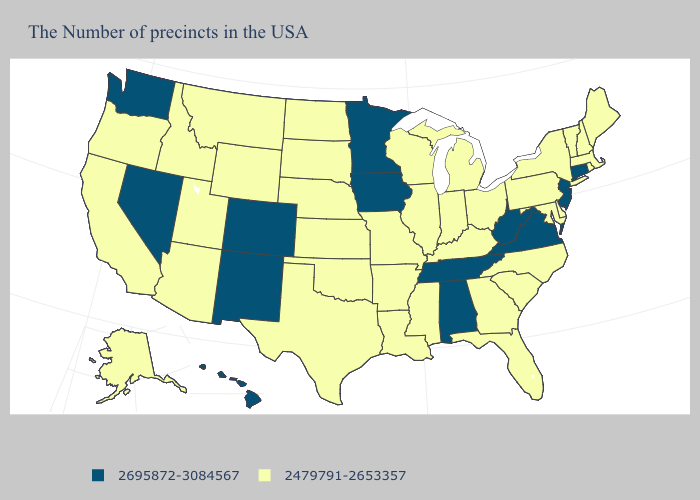Among the states that border North Carolina , does South Carolina have the lowest value?
Short answer required. Yes. Which states hav the highest value in the Northeast?
Quick response, please. Connecticut, New Jersey. Name the states that have a value in the range 2479791-2653357?
Give a very brief answer. Maine, Massachusetts, Rhode Island, New Hampshire, Vermont, New York, Delaware, Maryland, Pennsylvania, North Carolina, South Carolina, Ohio, Florida, Georgia, Michigan, Kentucky, Indiana, Wisconsin, Illinois, Mississippi, Louisiana, Missouri, Arkansas, Kansas, Nebraska, Oklahoma, Texas, South Dakota, North Dakota, Wyoming, Utah, Montana, Arizona, Idaho, California, Oregon, Alaska. Among the states that border Minnesota , does Iowa have the highest value?
Answer briefly. Yes. Name the states that have a value in the range 2695872-3084567?
Write a very short answer. Connecticut, New Jersey, Virginia, West Virginia, Alabama, Tennessee, Minnesota, Iowa, Colorado, New Mexico, Nevada, Washington, Hawaii. Name the states that have a value in the range 2695872-3084567?
Answer briefly. Connecticut, New Jersey, Virginia, West Virginia, Alabama, Tennessee, Minnesota, Iowa, Colorado, New Mexico, Nevada, Washington, Hawaii. What is the lowest value in the South?
Concise answer only. 2479791-2653357. Name the states that have a value in the range 2695872-3084567?
Answer briefly. Connecticut, New Jersey, Virginia, West Virginia, Alabama, Tennessee, Minnesota, Iowa, Colorado, New Mexico, Nevada, Washington, Hawaii. Name the states that have a value in the range 2479791-2653357?
Answer briefly. Maine, Massachusetts, Rhode Island, New Hampshire, Vermont, New York, Delaware, Maryland, Pennsylvania, North Carolina, South Carolina, Ohio, Florida, Georgia, Michigan, Kentucky, Indiana, Wisconsin, Illinois, Mississippi, Louisiana, Missouri, Arkansas, Kansas, Nebraska, Oklahoma, Texas, South Dakota, North Dakota, Wyoming, Utah, Montana, Arizona, Idaho, California, Oregon, Alaska. Name the states that have a value in the range 2479791-2653357?
Be succinct. Maine, Massachusetts, Rhode Island, New Hampshire, Vermont, New York, Delaware, Maryland, Pennsylvania, North Carolina, South Carolina, Ohio, Florida, Georgia, Michigan, Kentucky, Indiana, Wisconsin, Illinois, Mississippi, Louisiana, Missouri, Arkansas, Kansas, Nebraska, Oklahoma, Texas, South Dakota, North Dakota, Wyoming, Utah, Montana, Arizona, Idaho, California, Oregon, Alaska. What is the value of California?
Give a very brief answer. 2479791-2653357. What is the value of New York?
Quick response, please. 2479791-2653357. What is the highest value in the USA?
Answer briefly. 2695872-3084567. Name the states that have a value in the range 2695872-3084567?
Short answer required. Connecticut, New Jersey, Virginia, West Virginia, Alabama, Tennessee, Minnesota, Iowa, Colorado, New Mexico, Nevada, Washington, Hawaii. Name the states that have a value in the range 2479791-2653357?
Write a very short answer. Maine, Massachusetts, Rhode Island, New Hampshire, Vermont, New York, Delaware, Maryland, Pennsylvania, North Carolina, South Carolina, Ohio, Florida, Georgia, Michigan, Kentucky, Indiana, Wisconsin, Illinois, Mississippi, Louisiana, Missouri, Arkansas, Kansas, Nebraska, Oklahoma, Texas, South Dakota, North Dakota, Wyoming, Utah, Montana, Arizona, Idaho, California, Oregon, Alaska. 